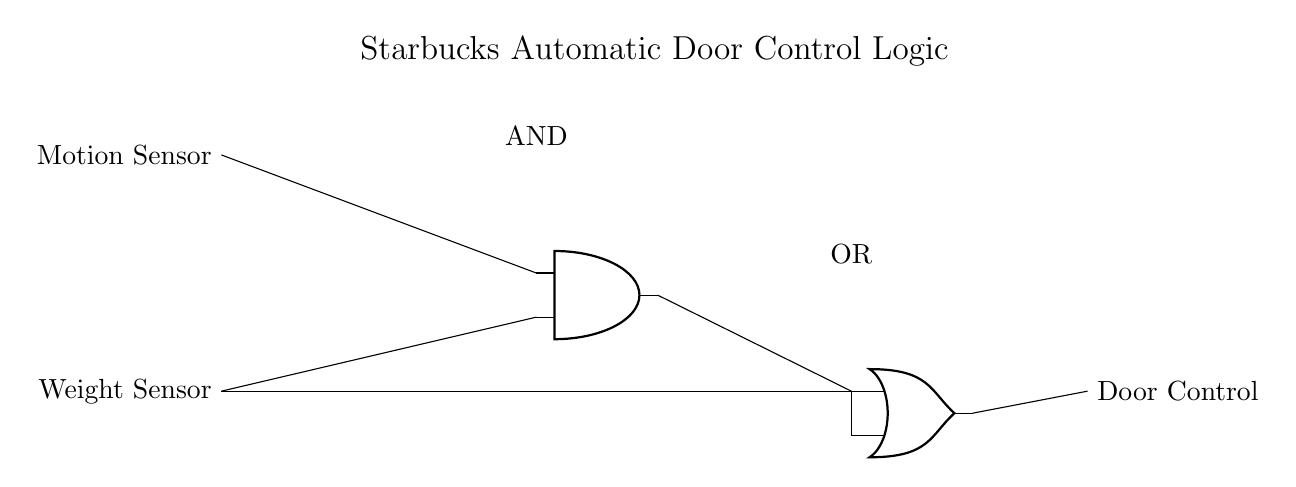What type of sensors are used in this circuit? The circuit diagram shows two input sensors: a motion sensor and a weight sensor. These are labeled in the circuit as they feed into the logic gates.
Answer: motion and weight sensors What logic gate combines the sensor inputs? The diagram indicates that the motion sensor and weight sensor are combined using an AND gate. The AND gate requires both conditions to be true for a signal to pass through.
Answer: AND What happens when both sensors are activated? When both sensors are activated, the AND gate outputs a signal to the OR gate. Since the OR gate also considers input from the weight sensor directly, the doors will open if either condition is met.
Answer: The door opens How many logic gates are in the circuit? The circuit diagram contains two logic gates: one AND gate and one OR gate, as shown with their respective symbols and connections.
Answer: 2 What is the function of the OR gate in this circuit? The OR gate's function is to output a signal to the door control system if either the AND gate outputs a signal (when both sensors are activated) or when the weight sensor is activated directly. This allows for flexibility in door control.
Answer: To provide door control signal when conditions are met Which input sensors are connected to the AND gate? The AND gate receives inputs from the motion sensor and weight sensor as shown in the connections leading into the AND gate. Both are necessary for the AND gate to pass a signal to the OR gate.
Answer: Motion and weight sensors 